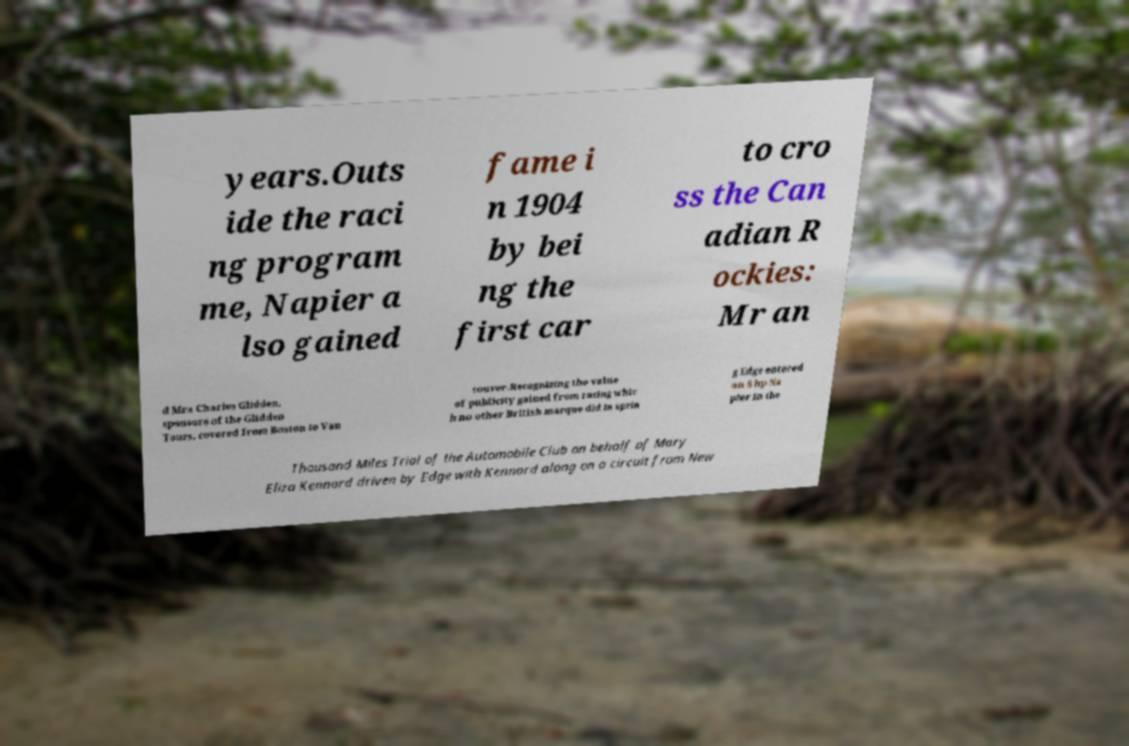There's text embedded in this image that I need extracted. Can you transcribe it verbatim? years.Outs ide the raci ng program me, Napier a lso gained fame i n 1904 by bei ng the first car to cro ss the Can adian R ockies: Mr an d Mrs Charles Glidden, sponsors of the Glidden Tours, covered from Boston to Van couver.Recognizing the value of publicity gained from racing whic h no other British marque did in sprin g Edge entered an 8 hp Na pier in the Thousand Miles Trial of the Automobile Club on behalf of Mary Eliza Kennard driven by Edge with Kennard along on a circuit from New 